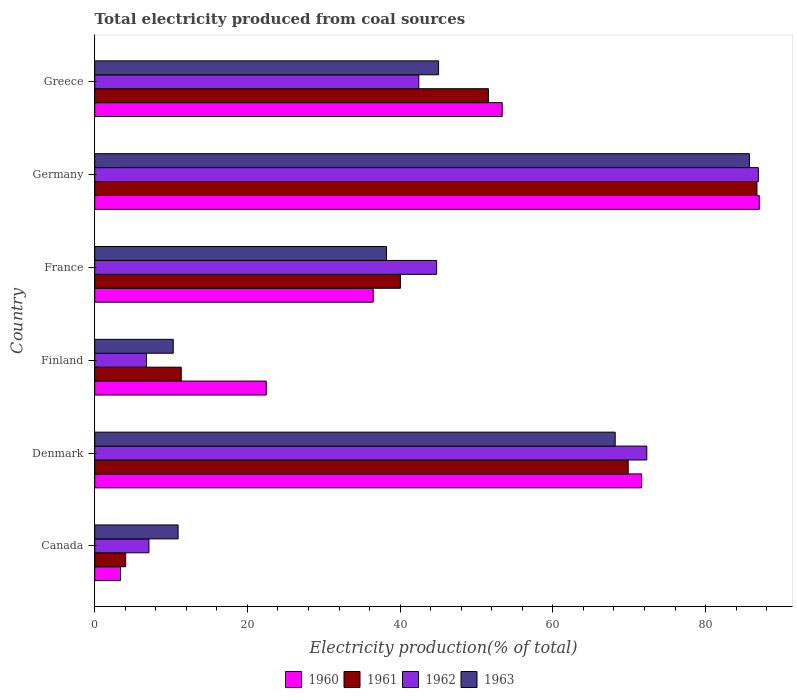Are the number of bars on each tick of the Y-axis equal?
Provide a short and direct response. Yes. How many bars are there on the 5th tick from the top?
Your answer should be very brief. 4. What is the label of the 4th group of bars from the top?
Keep it short and to the point. Finland. What is the total electricity produced in 1960 in Denmark?
Ensure brevity in your answer.  71.62. Across all countries, what is the maximum total electricity produced in 1963?
Your answer should be compact. 85.74. Across all countries, what is the minimum total electricity produced in 1962?
Provide a succinct answer. 6.78. In which country was the total electricity produced in 1963 minimum?
Provide a short and direct response. Finland. What is the total total electricity produced in 1962 in the graph?
Give a very brief answer. 260.3. What is the difference between the total electricity produced in 1960 in Finland and that in France?
Give a very brief answer. -14. What is the difference between the total electricity produced in 1961 in Germany and the total electricity produced in 1962 in Finland?
Offer a very short reply. 79.95. What is the average total electricity produced in 1960 per country?
Your answer should be compact. 45.72. What is the difference between the total electricity produced in 1961 and total electricity produced in 1963 in France?
Give a very brief answer. 1.82. What is the ratio of the total electricity produced in 1961 in Canada to that in Denmark?
Offer a terse response. 0.06. Is the total electricity produced in 1963 in Finland less than that in Greece?
Keep it short and to the point. Yes. Is the difference between the total electricity produced in 1961 in Canada and Germany greater than the difference between the total electricity produced in 1963 in Canada and Germany?
Your answer should be very brief. No. What is the difference between the highest and the second highest total electricity produced in 1962?
Offer a terse response. 14.61. What is the difference between the highest and the lowest total electricity produced in 1961?
Your response must be concise. 82.67. In how many countries, is the total electricity produced in 1962 greater than the average total electricity produced in 1962 taken over all countries?
Your response must be concise. 3. Is the sum of the total electricity produced in 1961 in Germany and Greece greater than the maximum total electricity produced in 1960 across all countries?
Provide a short and direct response. Yes. Is it the case that in every country, the sum of the total electricity produced in 1963 and total electricity produced in 1962 is greater than the sum of total electricity produced in 1961 and total electricity produced in 1960?
Your answer should be very brief. No. What does the 2nd bar from the top in Denmark represents?
Make the answer very short. 1962. What does the 2nd bar from the bottom in Finland represents?
Your answer should be compact. 1961. Is it the case that in every country, the sum of the total electricity produced in 1961 and total electricity produced in 1962 is greater than the total electricity produced in 1960?
Keep it short and to the point. No. How many bars are there?
Provide a succinct answer. 24. How many countries are there in the graph?
Give a very brief answer. 6. Are the values on the major ticks of X-axis written in scientific E-notation?
Your answer should be compact. No. Does the graph contain any zero values?
Offer a very short reply. No. Does the graph contain grids?
Offer a terse response. No. Where does the legend appear in the graph?
Provide a succinct answer. Bottom center. How are the legend labels stacked?
Ensure brevity in your answer.  Horizontal. What is the title of the graph?
Your answer should be very brief. Total electricity produced from coal sources. Does "1964" appear as one of the legend labels in the graph?
Provide a short and direct response. No. What is the Electricity production(% of total) in 1960 in Canada?
Provide a succinct answer. 3.38. What is the Electricity production(% of total) of 1961 in Canada?
Your answer should be very brief. 4.05. What is the Electricity production(% of total) in 1962 in Canada?
Provide a succinct answer. 7.1. What is the Electricity production(% of total) of 1963 in Canada?
Your response must be concise. 10.92. What is the Electricity production(% of total) in 1960 in Denmark?
Your response must be concise. 71.62. What is the Electricity production(% of total) of 1961 in Denmark?
Provide a succinct answer. 69.86. What is the Electricity production(% of total) in 1962 in Denmark?
Your answer should be compact. 72.3. What is the Electricity production(% of total) in 1963 in Denmark?
Give a very brief answer. 68.16. What is the Electricity production(% of total) of 1960 in Finland?
Provide a succinct answer. 22.46. What is the Electricity production(% of total) of 1961 in Finland?
Ensure brevity in your answer.  11.33. What is the Electricity production(% of total) of 1962 in Finland?
Your answer should be very brief. 6.78. What is the Electricity production(% of total) in 1963 in Finland?
Give a very brief answer. 10.28. What is the Electricity production(% of total) in 1960 in France?
Keep it short and to the point. 36.47. What is the Electricity production(% of total) of 1961 in France?
Offer a terse response. 40.03. What is the Electricity production(% of total) of 1962 in France?
Offer a very short reply. 44.78. What is the Electricity production(% of total) in 1963 in France?
Ensure brevity in your answer.  38.21. What is the Electricity production(% of total) in 1960 in Germany?
Your response must be concise. 87.03. What is the Electricity production(% of total) in 1961 in Germany?
Your answer should be compact. 86.73. What is the Electricity production(% of total) of 1962 in Germany?
Offer a terse response. 86.91. What is the Electricity production(% of total) in 1963 in Germany?
Offer a very short reply. 85.74. What is the Electricity production(% of total) in 1960 in Greece?
Your response must be concise. 53.36. What is the Electricity production(% of total) of 1961 in Greece?
Offer a terse response. 51.56. What is the Electricity production(% of total) of 1962 in Greece?
Your response must be concise. 42.44. What is the Electricity production(% of total) in 1963 in Greece?
Offer a terse response. 45.03. Across all countries, what is the maximum Electricity production(% of total) in 1960?
Your answer should be very brief. 87.03. Across all countries, what is the maximum Electricity production(% of total) of 1961?
Your response must be concise. 86.73. Across all countries, what is the maximum Electricity production(% of total) of 1962?
Your answer should be compact. 86.91. Across all countries, what is the maximum Electricity production(% of total) of 1963?
Provide a short and direct response. 85.74. Across all countries, what is the minimum Electricity production(% of total) in 1960?
Your response must be concise. 3.38. Across all countries, what is the minimum Electricity production(% of total) of 1961?
Your answer should be compact. 4.05. Across all countries, what is the minimum Electricity production(% of total) of 1962?
Make the answer very short. 6.78. Across all countries, what is the minimum Electricity production(% of total) of 1963?
Offer a terse response. 10.28. What is the total Electricity production(% of total) of 1960 in the graph?
Provide a short and direct response. 274.33. What is the total Electricity production(% of total) in 1961 in the graph?
Your answer should be very brief. 263.57. What is the total Electricity production(% of total) in 1962 in the graph?
Provide a succinct answer. 260.3. What is the total Electricity production(% of total) in 1963 in the graph?
Your answer should be very brief. 258.35. What is the difference between the Electricity production(% of total) in 1960 in Canada and that in Denmark?
Keep it short and to the point. -68.25. What is the difference between the Electricity production(% of total) of 1961 in Canada and that in Denmark?
Your answer should be very brief. -65.81. What is the difference between the Electricity production(% of total) of 1962 in Canada and that in Denmark?
Ensure brevity in your answer.  -65.2. What is the difference between the Electricity production(% of total) of 1963 in Canada and that in Denmark?
Offer a terse response. -57.24. What is the difference between the Electricity production(% of total) in 1960 in Canada and that in Finland?
Keep it short and to the point. -19.09. What is the difference between the Electricity production(% of total) of 1961 in Canada and that in Finland?
Offer a very short reply. -7.27. What is the difference between the Electricity production(% of total) in 1962 in Canada and that in Finland?
Give a very brief answer. 0.32. What is the difference between the Electricity production(% of total) of 1963 in Canada and that in Finland?
Your answer should be compact. 0.63. What is the difference between the Electricity production(% of total) in 1960 in Canada and that in France?
Provide a short and direct response. -33.09. What is the difference between the Electricity production(% of total) of 1961 in Canada and that in France?
Offer a very short reply. -35.98. What is the difference between the Electricity production(% of total) in 1962 in Canada and that in France?
Your response must be concise. -37.68. What is the difference between the Electricity production(% of total) of 1963 in Canada and that in France?
Offer a terse response. -27.29. What is the difference between the Electricity production(% of total) in 1960 in Canada and that in Germany?
Your answer should be very brief. -83.65. What is the difference between the Electricity production(% of total) in 1961 in Canada and that in Germany?
Provide a short and direct response. -82.67. What is the difference between the Electricity production(% of total) of 1962 in Canada and that in Germany?
Make the answer very short. -79.81. What is the difference between the Electricity production(% of total) of 1963 in Canada and that in Germany?
Your answer should be compact. -74.83. What is the difference between the Electricity production(% of total) of 1960 in Canada and that in Greece?
Provide a succinct answer. -49.98. What is the difference between the Electricity production(% of total) in 1961 in Canada and that in Greece?
Keep it short and to the point. -47.51. What is the difference between the Electricity production(% of total) in 1962 in Canada and that in Greece?
Offer a terse response. -35.34. What is the difference between the Electricity production(% of total) of 1963 in Canada and that in Greece?
Your response must be concise. -34.11. What is the difference between the Electricity production(% of total) in 1960 in Denmark and that in Finland?
Offer a terse response. 49.16. What is the difference between the Electricity production(% of total) in 1961 in Denmark and that in Finland?
Make the answer very short. 58.54. What is the difference between the Electricity production(% of total) of 1962 in Denmark and that in Finland?
Ensure brevity in your answer.  65.53. What is the difference between the Electricity production(% of total) of 1963 in Denmark and that in Finland?
Your response must be concise. 57.88. What is the difference between the Electricity production(% of total) of 1960 in Denmark and that in France?
Provide a short and direct response. 35.16. What is the difference between the Electricity production(% of total) in 1961 in Denmark and that in France?
Give a very brief answer. 29.83. What is the difference between the Electricity production(% of total) of 1962 in Denmark and that in France?
Provide a short and direct response. 27.52. What is the difference between the Electricity production(% of total) of 1963 in Denmark and that in France?
Provide a succinct answer. 29.95. What is the difference between the Electricity production(% of total) of 1960 in Denmark and that in Germany?
Provide a short and direct response. -15.4. What is the difference between the Electricity production(% of total) in 1961 in Denmark and that in Germany?
Your response must be concise. -16.86. What is the difference between the Electricity production(% of total) of 1962 in Denmark and that in Germany?
Provide a short and direct response. -14.61. What is the difference between the Electricity production(% of total) in 1963 in Denmark and that in Germany?
Make the answer very short. -17.58. What is the difference between the Electricity production(% of total) of 1960 in Denmark and that in Greece?
Provide a succinct answer. 18.26. What is the difference between the Electricity production(% of total) in 1961 in Denmark and that in Greece?
Offer a very short reply. 18.3. What is the difference between the Electricity production(% of total) in 1962 in Denmark and that in Greece?
Offer a terse response. 29.86. What is the difference between the Electricity production(% of total) in 1963 in Denmark and that in Greece?
Your response must be concise. 23.13. What is the difference between the Electricity production(% of total) in 1960 in Finland and that in France?
Make the answer very short. -14.01. What is the difference between the Electricity production(% of total) of 1961 in Finland and that in France?
Keep it short and to the point. -28.71. What is the difference between the Electricity production(% of total) in 1962 in Finland and that in France?
Offer a very short reply. -38. What is the difference between the Electricity production(% of total) of 1963 in Finland and that in France?
Your answer should be compact. -27.93. What is the difference between the Electricity production(% of total) of 1960 in Finland and that in Germany?
Give a very brief answer. -64.57. What is the difference between the Electricity production(% of total) of 1961 in Finland and that in Germany?
Make the answer very short. -75.4. What is the difference between the Electricity production(% of total) of 1962 in Finland and that in Germany?
Provide a succinct answer. -80.13. What is the difference between the Electricity production(% of total) of 1963 in Finland and that in Germany?
Your answer should be very brief. -75.46. What is the difference between the Electricity production(% of total) of 1960 in Finland and that in Greece?
Make the answer very short. -30.9. What is the difference between the Electricity production(% of total) in 1961 in Finland and that in Greece?
Your answer should be compact. -40.24. What is the difference between the Electricity production(% of total) in 1962 in Finland and that in Greece?
Your response must be concise. -35.66. What is the difference between the Electricity production(% of total) in 1963 in Finland and that in Greece?
Your answer should be very brief. -34.75. What is the difference between the Electricity production(% of total) of 1960 in France and that in Germany?
Your answer should be compact. -50.56. What is the difference between the Electricity production(% of total) in 1961 in France and that in Germany?
Your response must be concise. -46.69. What is the difference between the Electricity production(% of total) of 1962 in France and that in Germany?
Your answer should be compact. -42.13. What is the difference between the Electricity production(% of total) in 1963 in France and that in Germany?
Keep it short and to the point. -47.53. What is the difference between the Electricity production(% of total) of 1960 in France and that in Greece?
Give a very brief answer. -16.89. What is the difference between the Electricity production(% of total) of 1961 in France and that in Greece?
Offer a terse response. -11.53. What is the difference between the Electricity production(% of total) of 1962 in France and that in Greece?
Your answer should be compact. 2.34. What is the difference between the Electricity production(% of total) of 1963 in France and that in Greece?
Offer a very short reply. -6.82. What is the difference between the Electricity production(% of total) in 1960 in Germany and that in Greece?
Provide a succinct answer. 33.67. What is the difference between the Electricity production(% of total) of 1961 in Germany and that in Greece?
Give a very brief answer. 35.16. What is the difference between the Electricity production(% of total) of 1962 in Germany and that in Greece?
Your answer should be very brief. 44.47. What is the difference between the Electricity production(% of total) in 1963 in Germany and that in Greece?
Provide a short and direct response. 40.71. What is the difference between the Electricity production(% of total) of 1960 in Canada and the Electricity production(% of total) of 1961 in Denmark?
Give a very brief answer. -66.49. What is the difference between the Electricity production(% of total) in 1960 in Canada and the Electricity production(% of total) in 1962 in Denmark?
Ensure brevity in your answer.  -68.92. What is the difference between the Electricity production(% of total) of 1960 in Canada and the Electricity production(% of total) of 1963 in Denmark?
Keep it short and to the point. -64.78. What is the difference between the Electricity production(% of total) in 1961 in Canada and the Electricity production(% of total) in 1962 in Denmark?
Your response must be concise. -68.25. What is the difference between the Electricity production(% of total) of 1961 in Canada and the Electricity production(% of total) of 1963 in Denmark?
Offer a very short reply. -64.11. What is the difference between the Electricity production(% of total) in 1962 in Canada and the Electricity production(% of total) in 1963 in Denmark?
Offer a very short reply. -61.06. What is the difference between the Electricity production(% of total) of 1960 in Canada and the Electricity production(% of total) of 1961 in Finland?
Ensure brevity in your answer.  -7.95. What is the difference between the Electricity production(% of total) of 1960 in Canada and the Electricity production(% of total) of 1962 in Finland?
Keep it short and to the point. -3.4. What is the difference between the Electricity production(% of total) of 1960 in Canada and the Electricity production(% of total) of 1963 in Finland?
Provide a short and direct response. -6.91. What is the difference between the Electricity production(% of total) of 1961 in Canada and the Electricity production(% of total) of 1962 in Finland?
Ensure brevity in your answer.  -2.72. What is the difference between the Electricity production(% of total) in 1961 in Canada and the Electricity production(% of total) in 1963 in Finland?
Your response must be concise. -6.23. What is the difference between the Electricity production(% of total) of 1962 in Canada and the Electricity production(% of total) of 1963 in Finland?
Ensure brevity in your answer.  -3.18. What is the difference between the Electricity production(% of total) of 1960 in Canada and the Electricity production(% of total) of 1961 in France?
Your response must be concise. -36.66. What is the difference between the Electricity production(% of total) in 1960 in Canada and the Electricity production(% of total) in 1962 in France?
Offer a terse response. -41.4. What is the difference between the Electricity production(% of total) in 1960 in Canada and the Electricity production(% of total) in 1963 in France?
Provide a short and direct response. -34.83. What is the difference between the Electricity production(% of total) in 1961 in Canada and the Electricity production(% of total) in 1962 in France?
Ensure brevity in your answer.  -40.72. What is the difference between the Electricity production(% of total) of 1961 in Canada and the Electricity production(% of total) of 1963 in France?
Provide a short and direct response. -34.16. What is the difference between the Electricity production(% of total) in 1962 in Canada and the Electricity production(% of total) in 1963 in France?
Keep it short and to the point. -31.11. What is the difference between the Electricity production(% of total) in 1960 in Canada and the Electricity production(% of total) in 1961 in Germany?
Provide a short and direct response. -83.35. What is the difference between the Electricity production(% of total) of 1960 in Canada and the Electricity production(% of total) of 1962 in Germany?
Offer a terse response. -83.53. What is the difference between the Electricity production(% of total) in 1960 in Canada and the Electricity production(% of total) in 1963 in Germany?
Give a very brief answer. -82.36. What is the difference between the Electricity production(% of total) of 1961 in Canada and the Electricity production(% of total) of 1962 in Germany?
Offer a very short reply. -82.86. What is the difference between the Electricity production(% of total) in 1961 in Canada and the Electricity production(% of total) in 1963 in Germany?
Ensure brevity in your answer.  -81.69. What is the difference between the Electricity production(% of total) in 1962 in Canada and the Electricity production(% of total) in 1963 in Germany?
Provide a short and direct response. -78.64. What is the difference between the Electricity production(% of total) of 1960 in Canada and the Electricity production(% of total) of 1961 in Greece?
Provide a succinct answer. -48.19. What is the difference between the Electricity production(% of total) in 1960 in Canada and the Electricity production(% of total) in 1962 in Greece?
Keep it short and to the point. -39.06. What is the difference between the Electricity production(% of total) in 1960 in Canada and the Electricity production(% of total) in 1963 in Greece?
Offer a very short reply. -41.65. What is the difference between the Electricity production(% of total) in 1961 in Canada and the Electricity production(% of total) in 1962 in Greece?
Offer a terse response. -38.39. What is the difference between the Electricity production(% of total) of 1961 in Canada and the Electricity production(% of total) of 1963 in Greece?
Give a very brief answer. -40.98. What is the difference between the Electricity production(% of total) in 1962 in Canada and the Electricity production(% of total) in 1963 in Greece?
Give a very brief answer. -37.93. What is the difference between the Electricity production(% of total) of 1960 in Denmark and the Electricity production(% of total) of 1961 in Finland?
Ensure brevity in your answer.  60.3. What is the difference between the Electricity production(% of total) of 1960 in Denmark and the Electricity production(% of total) of 1962 in Finland?
Offer a terse response. 64.85. What is the difference between the Electricity production(% of total) in 1960 in Denmark and the Electricity production(% of total) in 1963 in Finland?
Ensure brevity in your answer.  61.34. What is the difference between the Electricity production(% of total) of 1961 in Denmark and the Electricity production(% of total) of 1962 in Finland?
Make the answer very short. 63.09. What is the difference between the Electricity production(% of total) of 1961 in Denmark and the Electricity production(% of total) of 1963 in Finland?
Your response must be concise. 59.58. What is the difference between the Electricity production(% of total) of 1962 in Denmark and the Electricity production(% of total) of 1963 in Finland?
Offer a very short reply. 62.02. What is the difference between the Electricity production(% of total) of 1960 in Denmark and the Electricity production(% of total) of 1961 in France?
Your response must be concise. 31.59. What is the difference between the Electricity production(% of total) in 1960 in Denmark and the Electricity production(% of total) in 1962 in France?
Provide a succinct answer. 26.85. What is the difference between the Electricity production(% of total) of 1960 in Denmark and the Electricity production(% of total) of 1963 in France?
Ensure brevity in your answer.  33.41. What is the difference between the Electricity production(% of total) in 1961 in Denmark and the Electricity production(% of total) in 1962 in France?
Ensure brevity in your answer.  25.09. What is the difference between the Electricity production(% of total) of 1961 in Denmark and the Electricity production(% of total) of 1963 in France?
Your answer should be very brief. 31.65. What is the difference between the Electricity production(% of total) of 1962 in Denmark and the Electricity production(% of total) of 1963 in France?
Make the answer very short. 34.09. What is the difference between the Electricity production(% of total) of 1960 in Denmark and the Electricity production(% of total) of 1961 in Germany?
Provide a short and direct response. -15.1. What is the difference between the Electricity production(% of total) of 1960 in Denmark and the Electricity production(% of total) of 1962 in Germany?
Offer a terse response. -15.28. What is the difference between the Electricity production(% of total) of 1960 in Denmark and the Electricity production(% of total) of 1963 in Germany?
Offer a very short reply. -14.12. What is the difference between the Electricity production(% of total) in 1961 in Denmark and the Electricity production(% of total) in 1962 in Germany?
Your answer should be very brief. -17.04. What is the difference between the Electricity production(% of total) of 1961 in Denmark and the Electricity production(% of total) of 1963 in Germany?
Offer a terse response. -15.88. What is the difference between the Electricity production(% of total) in 1962 in Denmark and the Electricity production(% of total) in 1963 in Germany?
Keep it short and to the point. -13.44. What is the difference between the Electricity production(% of total) of 1960 in Denmark and the Electricity production(% of total) of 1961 in Greece?
Provide a succinct answer. 20.06. What is the difference between the Electricity production(% of total) of 1960 in Denmark and the Electricity production(% of total) of 1962 in Greece?
Give a very brief answer. 29.18. What is the difference between the Electricity production(% of total) of 1960 in Denmark and the Electricity production(% of total) of 1963 in Greece?
Offer a terse response. 26.59. What is the difference between the Electricity production(% of total) in 1961 in Denmark and the Electricity production(% of total) in 1962 in Greece?
Provide a succinct answer. 27.42. What is the difference between the Electricity production(% of total) in 1961 in Denmark and the Electricity production(% of total) in 1963 in Greece?
Your response must be concise. 24.83. What is the difference between the Electricity production(% of total) of 1962 in Denmark and the Electricity production(% of total) of 1963 in Greece?
Make the answer very short. 27.27. What is the difference between the Electricity production(% of total) in 1960 in Finland and the Electricity production(% of total) in 1961 in France?
Keep it short and to the point. -17.57. What is the difference between the Electricity production(% of total) in 1960 in Finland and the Electricity production(% of total) in 1962 in France?
Your answer should be compact. -22.31. What is the difference between the Electricity production(% of total) of 1960 in Finland and the Electricity production(% of total) of 1963 in France?
Give a very brief answer. -15.75. What is the difference between the Electricity production(% of total) in 1961 in Finland and the Electricity production(% of total) in 1962 in France?
Provide a succinct answer. -33.45. What is the difference between the Electricity production(% of total) of 1961 in Finland and the Electricity production(% of total) of 1963 in France?
Your answer should be very brief. -26.88. What is the difference between the Electricity production(% of total) of 1962 in Finland and the Electricity production(% of total) of 1963 in France?
Keep it short and to the point. -31.44. What is the difference between the Electricity production(% of total) in 1960 in Finland and the Electricity production(% of total) in 1961 in Germany?
Keep it short and to the point. -64.26. What is the difference between the Electricity production(% of total) of 1960 in Finland and the Electricity production(% of total) of 1962 in Germany?
Make the answer very short. -64.45. What is the difference between the Electricity production(% of total) in 1960 in Finland and the Electricity production(% of total) in 1963 in Germany?
Ensure brevity in your answer.  -63.28. What is the difference between the Electricity production(% of total) in 1961 in Finland and the Electricity production(% of total) in 1962 in Germany?
Keep it short and to the point. -75.58. What is the difference between the Electricity production(% of total) in 1961 in Finland and the Electricity production(% of total) in 1963 in Germany?
Ensure brevity in your answer.  -74.41. What is the difference between the Electricity production(% of total) in 1962 in Finland and the Electricity production(% of total) in 1963 in Germany?
Provide a succinct answer. -78.97. What is the difference between the Electricity production(% of total) of 1960 in Finland and the Electricity production(% of total) of 1961 in Greece?
Provide a succinct answer. -29.1. What is the difference between the Electricity production(% of total) in 1960 in Finland and the Electricity production(% of total) in 1962 in Greece?
Your answer should be very brief. -19.98. What is the difference between the Electricity production(% of total) in 1960 in Finland and the Electricity production(% of total) in 1963 in Greece?
Keep it short and to the point. -22.57. What is the difference between the Electricity production(% of total) of 1961 in Finland and the Electricity production(% of total) of 1962 in Greece?
Provide a succinct answer. -31.11. What is the difference between the Electricity production(% of total) in 1961 in Finland and the Electricity production(% of total) in 1963 in Greece?
Make the answer very short. -33.7. What is the difference between the Electricity production(% of total) in 1962 in Finland and the Electricity production(% of total) in 1963 in Greece?
Offer a terse response. -38.26. What is the difference between the Electricity production(% of total) of 1960 in France and the Electricity production(% of total) of 1961 in Germany?
Ensure brevity in your answer.  -50.26. What is the difference between the Electricity production(% of total) of 1960 in France and the Electricity production(% of total) of 1962 in Germany?
Give a very brief answer. -50.44. What is the difference between the Electricity production(% of total) of 1960 in France and the Electricity production(% of total) of 1963 in Germany?
Your response must be concise. -49.27. What is the difference between the Electricity production(% of total) in 1961 in France and the Electricity production(% of total) in 1962 in Germany?
Make the answer very short. -46.87. What is the difference between the Electricity production(% of total) in 1961 in France and the Electricity production(% of total) in 1963 in Germany?
Your response must be concise. -45.71. What is the difference between the Electricity production(% of total) in 1962 in France and the Electricity production(% of total) in 1963 in Germany?
Give a very brief answer. -40.97. What is the difference between the Electricity production(% of total) of 1960 in France and the Electricity production(% of total) of 1961 in Greece?
Your response must be concise. -15.09. What is the difference between the Electricity production(% of total) of 1960 in France and the Electricity production(% of total) of 1962 in Greece?
Offer a very short reply. -5.97. What is the difference between the Electricity production(% of total) of 1960 in France and the Electricity production(% of total) of 1963 in Greece?
Offer a very short reply. -8.56. What is the difference between the Electricity production(% of total) in 1961 in France and the Electricity production(% of total) in 1962 in Greece?
Offer a very short reply. -2.41. What is the difference between the Electricity production(% of total) in 1961 in France and the Electricity production(% of total) in 1963 in Greece?
Give a very brief answer. -5. What is the difference between the Electricity production(% of total) of 1962 in France and the Electricity production(% of total) of 1963 in Greece?
Provide a short and direct response. -0.25. What is the difference between the Electricity production(% of total) of 1960 in Germany and the Electricity production(% of total) of 1961 in Greece?
Keep it short and to the point. 35.47. What is the difference between the Electricity production(% of total) of 1960 in Germany and the Electricity production(% of total) of 1962 in Greece?
Make the answer very short. 44.59. What is the difference between the Electricity production(% of total) in 1960 in Germany and the Electricity production(% of total) in 1963 in Greece?
Make the answer very short. 42. What is the difference between the Electricity production(% of total) in 1961 in Germany and the Electricity production(% of total) in 1962 in Greece?
Your response must be concise. 44.29. What is the difference between the Electricity production(% of total) in 1961 in Germany and the Electricity production(% of total) in 1963 in Greece?
Keep it short and to the point. 41.69. What is the difference between the Electricity production(% of total) of 1962 in Germany and the Electricity production(% of total) of 1963 in Greece?
Provide a succinct answer. 41.88. What is the average Electricity production(% of total) of 1960 per country?
Your response must be concise. 45.72. What is the average Electricity production(% of total) in 1961 per country?
Keep it short and to the point. 43.93. What is the average Electricity production(% of total) in 1962 per country?
Make the answer very short. 43.38. What is the average Electricity production(% of total) in 1963 per country?
Give a very brief answer. 43.06. What is the difference between the Electricity production(% of total) of 1960 and Electricity production(% of total) of 1961 in Canada?
Your response must be concise. -0.68. What is the difference between the Electricity production(% of total) of 1960 and Electricity production(% of total) of 1962 in Canada?
Your response must be concise. -3.72. What is the difference between the Electricity production(% of total) in 1960 and Electricity production(% of total) in 1963 in Canada?
Offer a very short reply. -7.54. What is the difference between the Electricity production(% of total) in 1961 and Electricity production(% of total) in 1962 in Canada?
Provide a succinct answer. -3.04. What is the difference between the Electricity production(% of total) of 1961 and Electricity production(% of total) of 1963 in Canada?
Provide a succinct answer. -6.86. What is the difference between the Electricity production(% of total) in 1962 and Electricity production(% of total) in 1963 in Canada?
Offer a terse response. -3.82. What is the difference between the Electricity production(% of total) of 1960 and Electricity production(% of total) of 1961 in Denmark?
Your response must be concise. 1.76. What is the difference between the Electricity production(% of total) of 1960 and Electricity production(% of total) of 1962 in Denmark?
Your answer should be compact. -0.68. What is the difference between the Electricity production(% of total) in 1960 and Electricity production(% of total) in 1963 in Denmark?
Keep it short and to the point. 3.46. What is the difference between the Electricity production(% of total) in 1961 and Electricity production(% of total) in 1962 in Denmark?
Your answer should be compact. -2.44. What is the difference between the Electricity production(% of total) in 1961 and Electricity production(% of total) in 1963 in Denmark?
Your response must be concise. 1.7. What is the difference between the Electricity production(% of total) in 1962 and Electricity production(% of total) in 1963 in Denmark?
Keep it short and to the point. 4.14. What is the difference between the Electricity production(% of total) of 1960 and Electricity production(% of total) of 1961 in Finland?
Give a very brief answer. 11.14. What is the difference between the Electricity production(% of total) of 1960 and Electricity production(% of total) of 1962 in Finland?
Provide a succinct answer. 15.69. What is the difference between the Electricity production(% of total) of 1960 and Electricity production(% of total) of 1963 in Finland?
Offer a very short reply. 12.18. What is the difference between the Electricity production(% of total) in 1961 and Electricity production(% of total) in 1962 in Finland?
Give a very brief answer. 4.55. What is the difference between the Electricity production(% of total) of 1961 and Electricity production(% of total) of 1963 in Finland?
Your response must be concise. 1.04. What is the difference between the Electricity production(% of total) of 1962 and Electricity production(% of total) of 1963 in Finland?
Give a very brief answer. -3.51. What is the difference between the Electricity production(% of total) of 1960 and Electricity production(% of total) of 1961 in France?
Give a very brief answer. -3.57. What is the difference between the Electricity production(% of total) in 1960 and Electricity production(% of total) in 1962 in France?
Your answer should be very brief. -8.31. What is the difference between the Electricity production(% of total) of 1960 and Electricity production(% of total) of 1963 in France?
Offer a terse response. -1.74. What is the difference between the Electricity production(% of total) of 1961 and Electricity production(% of total) of 1962 in France?
Make the answer very short. -4.74. What is the difference between the Electricity production(% of total) of 1961 and Electricity production(% of total) of 1963 in France?
Keep it short and to the point. 1.82. What is the difference between the Electricity production(% of total) of 1962 and Electricity production(% of total) of 1963 in France?
Ensure brevity in your answer.  6.57. What is the difference between the Electricity production(% of total) of 1960 and Electricity production(% of total) of 1961 in Germany?
Provide a succinct answer. 0.3. What is the difference between the Electricity production(% of total) of 1960 and Electricity production(% of total) of 1962 in Germany?
Your answer should be compact. 0.12. What is the difference between the Electricity production(% of total) in 1960 and Electricity production(% of total) in 1963 in Germany?
Keep it short and to the point. 1.29. What is the difference between the Electricity production(% of total) in 1961 and Electricity production(% of total) in 1962 in Germany?
Give a very brief answer. -0.18. What is the difference between the Electricity production(% of total) of 1961 and Electricity production(% of total) of 1963 in Germany?
Provide a succinct answer. 0.98. What is the difference between the Electricity production(% of total) in 1962 and Electricity production(% of total) in 1963 in Germany?
Make the answer very short. 1.17. What is the difference between the Electricity production(% of total) of 1960 and Electricity production(% of total) of 1961 in Greece?
Give a very brief answer. 1.8. What is the difference between the Electricity production(% of total) of 1960 and Electricity production(% of total) of 1962 in Greece?
Your answer should be compact. 10.92. What is the difference between the Electricity production(% of total) in 1960 and Electricity production(% of total) in 1963 in Greece?
Provide a short and direct response. 8.33. What is the difference between the Electricity production(% of total) of 1961 and Electricity production(% of total) of 1962 in Greece?
Provide a short and direct response. 9.12. What is the difference between the Electricity production(% of total) of 1961 and Electricity production(% of total) of 1963 in Greece?
Your response must be concise. 6.53. What is the difference between the Electricity production(% of total) in 1962 and Electricity production(% of total) in 1963 in Greece?
Offer a very short reply. -2.59. What is the ratio of the Electricity production(% of total) in 1960 in Canada to that in Denmark?
Provide a succinct answer. 0.05. What is the ratio of the Electricity production(% of total) of 1961 in Canada to that in Denmark?
Provide a short and direct response. 0.06. What is the ratio of the Electricity production(% of total) in 1962 in Canada to that in Denmark?
Give a very brief answer. 0.1. What is the ratio of the Electricity production(% of total) in 1963 in Canada to that in Denmark?
Offer a terse response. 0.16. What is the ratio of the Electricity production(% of total) of 1960 in Canada to that in Finland?
Provide a short and direct response. 0.15. What is the ratio of the Electricity production(% of total) of 1961 in Canada to that in Finland?
Your answer should be compact. 0.36. What is the ratio of the Electricity production(% of total) in 1962 in Canada to that in Finland?
Offer a terse response. 1.05. What is the ratio of the Electricity production(% of total) in 1963 in Canada to that in Finland?
Provide a succinct answer. 1.06. What is the ratio of the Electricity production(% of total) of 1960 in Canada to that in France?
Offer a terse response. 0.09. What is the ratio of the Electricity production(% of total) in 1961 in Canada to that in France?
Give a very brief answer. 0.1. What is the ratio of the Electricity production(% of total) of 1962 in Canada to that in France?
Your answer should be compact. 0.16. What is the ratio of the Electricity production(% of total) of 1963 in Canada to that in France?
Your response must be concise. 0.29. What is the ratio of the Electricity production(% of total) of 1960 in Canada to that in Germany?
Offer a terse response. 0.04. What is the ratio of the Electricity production(% of total) in 1961 in Canada to that in Germany?
Provide a short and direct response. 0.05. What is the ratio of the Electricity production(% of total) in 1962 in Canada to that in Germany?
Your response must be concise. 0.08. What is the ratio of the Electricity production(% of total) of 1963 in Canada to that in Germany?
Ensure brevity in your answer.  0.13. What is the ratio of the Electricity production(% of total) of 1960 in Canada to that in Greece?
Ensure brevity in your answer.  0.06. What is the ratio of the Electricity production(% of total) in 1961 in Canada to that in Greece?
Ensure brevity in your answer.  0.08. What is the ratio of the Electricity production(% of total) in 1962 in Canada to that in Greece?
Ensure brevity in your answer.  0.17. What is the ratio of the Electricity production(% of total) of 1963 in Canada to that in Greece?
Your answer should be very brief. 0.24. What is the ratio of the Electricity production(% of total) in 1960 in Denmark to that in Finland?
Provide a short and direct response. 3.19. What is the ratio of the Electricity production(% of total) in 1961 in Denmark to that in Finland?
Provide a succinct answer. 6.17. What is the ratio of the Electricity production(% of total) of 1962 in Denmark to that in Finland?
Keep it short and to the point. 10.67. What is the ratio of the Electricity production(% of total) of 1963 in Denmark to that in Finland?
Your response must be concise. 6.63. What is the ratio of the Electricity production(% of total) of 1960 in Denmark to that in France?
Your answer should be compact. 1.96. What is the ratio of the Electricity production(% of total) in 1961 in Denmark to that in France?
Your answer should be compact. 1.75. What is the ratio of the Electricity production(% of total) of 1962 in Denmark to that in France?
Ensure brevity in your answer.  1.61. What is the ratio of the Electricity production(% of total) in 1963 in Denmark to that in France?
Give a very brief answer. 1.78. What is the ratio of the Electricity production(% of total) of 1960 in Denmark to that in Germany?
Keep it short and to the point. 0.82. What is the ratio of the Electricity production(% of total) in 1961 in Denmark to that in Germany?
Provide a succinct answer. 0.81. What is the ratio of the Electricity production(% of total) in 1962 in Denmark to that in Germany?
Keep it short and to the point. 0.83. What is the ratio of the Electricity production(% of total) of 1963 in Denmark to that in Germany?
Your response must be concise. 0.79. What is the ratio of the Electricity production(% of total) of 1960 in Denmark to that in Greece?
Make the answer very short. 1.34. What is the ratio of the Electricity production(% of total) in 1961 in Denmark to that in Greece?
Give a very brief answer. 1.35. What is the ratio of the Electricity production(% of total) in 1962 in Denmark to that in Greece?
Your response must be concise. 1.7. What is the ratio of the Electricity production(% of total) in 1963 in Denmark to that in Greece?
Ensure brevity in your answer.  1.51. What is the ratio of the Electricity production(% of total) in 1960 in Finland to that in France?
Keep it short and to the point. 0.62. What is the ratio of the Electricity production(% of total) of 1961 in Finland to that in France?
Provide a short and direct response. 0.28. What is the ratio of the Electricity production(% of total) of 1962 in Finland to that in France?
Your answer should be compact. 0.15. What is the ratio of the Electricity production(% of total) of 1963 in Finland to that in France?
Provide a short and direct response. 0.27. What is the ratio of the Electricity production(% of total) of 1960 in Finland to that in Germany?
Offer a very short reply. 0.26. What is the ratio of the Electricity production(% of total) of 1961 in Finland to that in Germany?
Give a very brief answer. 0.13. What is the ratio of the Electricity production(% of total) in 1962 in Finland to that in Germany?
Your answer should be very brief. 0.08. What is the ratio of the Electricity production(% of total) of 1963 in Finland to that in Germany?
Ensure brevity in your answer.  0.12. What is the ratio of the Electricity production(% of total) in 1960 in Finland to that in Greece?
Provide a succinct answer. 0.42. What is the ratio of the Electricity production(% of total) of 1961 in Finland to that in Greece?
Give a very brief answer. 0.22. What is the ratio of the Electricity production(% of total) in 1962 in Finland to that in Greece?
Provide a succinct answer. 0.16. What is the ratio of the Electricity production(% of total) in 1963 in Finland to that in Greece?
Offer a very short reply. 0.23. What is the ratio of the Electricity production(% of total) of 1960 in France to that in Germany?
Ensure brevity in your answer.  0.42. What is the ratio of the Electricity production(% of total) in 1961 in France to that in Germany?
Your response must be concise. 0.46. What is the ratio of the Electricity production(% of total) of 1962 in France to that in Germany?
Provide a short and direct response. 0.52. What is the ratio of the Electricity production(% of total) of 1963 in France to that in Germany?
Your response must be concise. 0.45. What is the ratio of the Electricity production(% of total) in 1960 in France to that in Greece?
Offer a terse response. 0.68. What is the ratio of the Electricity production(% of total) of 1961 in France to that in Greece?
Make the answer very short. 0.78. What is the ratio of the Electricity production(% of total) of 1962 in France to that in Greece?
Your answer should be compact. 1.06. What is the ratio of the Electricity production(% of total) in 1963 in France to that in Greece?
Provide a succinct answer. 0.85. What is the ratio of the Electricity production(% of total) in 1960 in Germany to that in Greece?
Your answer should be very brief. 1.63. What is the ratio of the Electricity production(% of total) of 1961 in Germany to that in Greece?
Your response must be concise. 1.68. What is the ratio of the Electricity production(% of total) in 1962 in Germany to that in Greece?
Provide a short and direct response. 2.05. What is the ratio of the Electricity production(% of total) of 1963 in Germany to that in Greece?
Your response must be concise. 1.9. What is the difference between the highest and the second highest Electricity production(% of total) of 1960?
Your answer should be compact. 15.4. What is the difference between the highest and the second highest Electricity production(% of total) in 1961?
Keep it short and to the point. 16.86. What is the difference between the highest and the second highest Electricity production(% of total) of 1962?
Keep it short and to the point. 14.61. What is the difference between the highest and the second highest Electricity production(% of total) in 1963?
Offer a terse response. 17.58. What is the difference between the highest and the lowest Electricity production(% of total) in 1960?
Give a very brief answer. 83.65. What is the difference between the highest and the lowest Electricity production(% of total) of 1961?
Make the answer very short. 82.67. What is the difference between the highest and the lowest Electricity production(% of total) of 1962?
Ensure brevity in your answer.  80.13. What is the difference between the highest and the lowest Electricity production(% of total) in 1963?
Give a very brief answer. 75.46. 